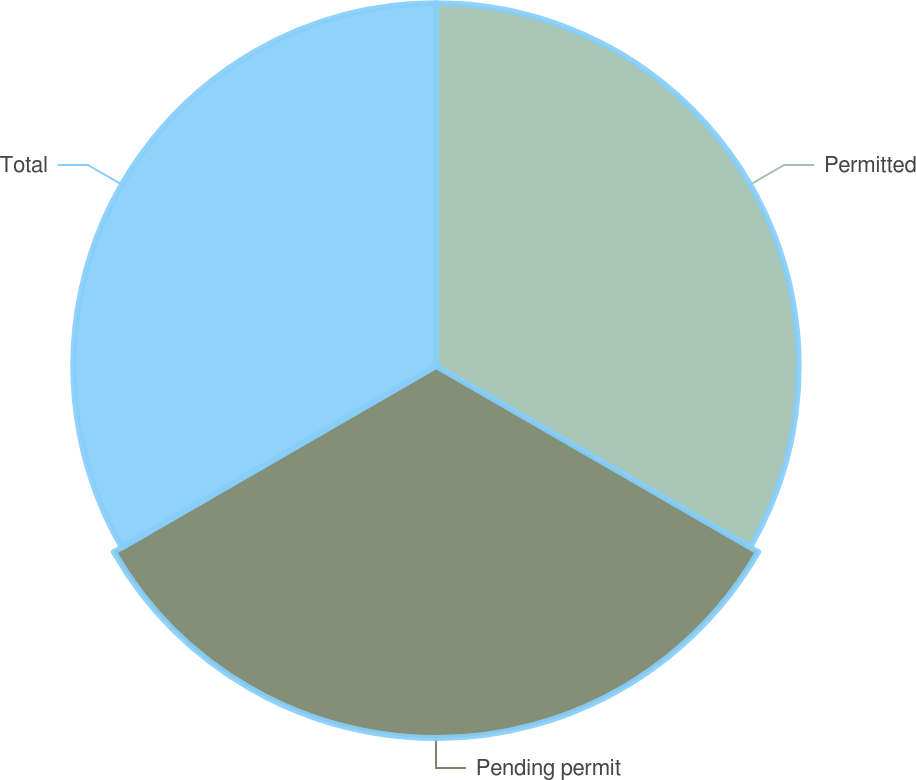<chart> <loc_0><loc_0><loc_500><loc_500><pie_chart><fcel>Permitted<fcel>Pending permit<fcel>Total<nl><fcel>33.05%<fcel>33.9%<fcel>33.05%<nl></chart> 